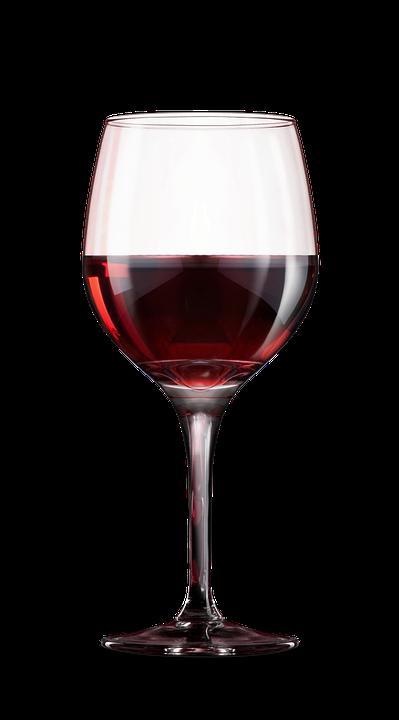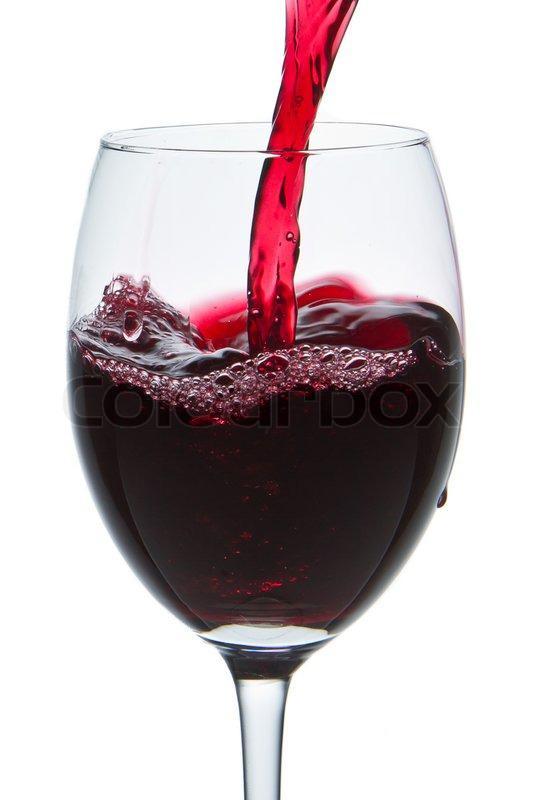The first image is the image on the left, the second image is the image on the right. Examine the images to the left and right. Is the description "Wine is pouring into the glass in the image on the right." accurate? Answer yes or no. Yes. The first image is the image on the left, the second image is the image on the right. Given the left and right images, does the statement "Red wine is pouring into a glass, creating a splash inside the glass." hold true? Answer yes or no. Yes. 